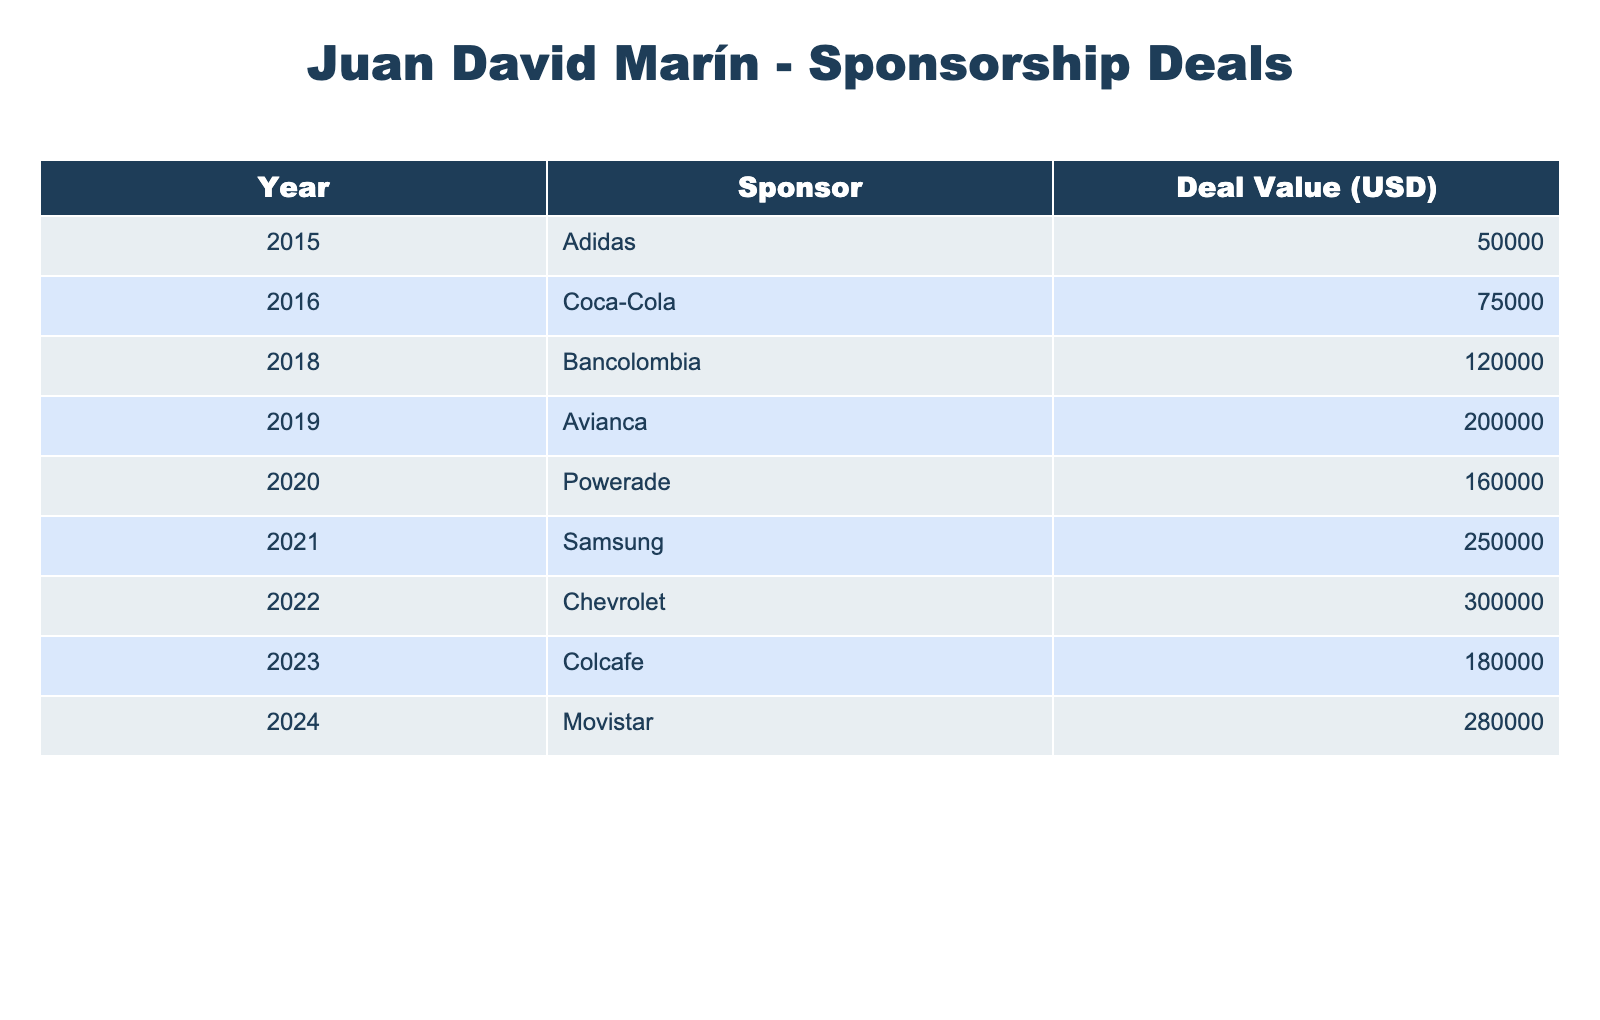What was the value of the sponsorship deal with Bancolombia? The table shows that the deal value for Bancolombia in 2018 was 120,000 USD.
Answer: 120,000 USD Which sponsor had the highest deal value in 2022? According to the table, Chevrolet had the highest deal value in 2022 at 300,000 USD.
Answer: Chevrolet What is the total value of all sponsorship deals from 2015 to 2023? Adding all the deal values: 50,000 + 75,000 + 120,000 + 200,000 + 160,000 + 250,000 + 300,000 + 180,000 = 1,135,000 USD.
Answer: 1,135,000 USD Is the deal value with Movistar greater than that with Coca-Cola? The value for Movistar in 2024 is 280,000 USD, and for Coca-Cola in 2016 it was 75,000 USD, so yes, 280,000 is greater than 75,000.
Answer: Yes What was the average deal value from 2015 to 2023? The total deal value is 1,135,000 USD and there are 9 years so, average = 1,135,000 / 9 = 126,111.11 USD, rounded to 126,111 USD.
Answer: 126,111 USD In which year did Juan David Marín get the first sponsorship deal? The first sponsorship deal mentioned in the table was with Adidas in 2015.
Answer: 2015 How many sponsorship deals have a value over 200,000 USD? The deals over 200,000 USD were with Avianca (200,000), Samsung (250,000), Chevrolet (300,000), and Movistar (280,000), totaling 4 deals.
Answer: 4 Which years did Juan David Marín secure sponsorships from Coca-Cola and Powerade? Coca-Cola was secured in 2016, and Powerade was secured in 2020, according to the table.
Answer: 2016 and 2020 What was the percentage increase in the deal value from 2019 (Avianca) to 2020 (Powerade)? The deal increases from 200,000 to 160,000: the difference is -40,000. The percentage is (-40,000 / 200,000) * 100 = -20%, indicating a decrease.
Answer: -20% What year showed the highest increase in sponsorship deal value compared to the previous year? The highest increase was from 2021 (250,000) to 2022 (300,000), which is an increase of 50,000, the highest among all years.
Answer: 2022 